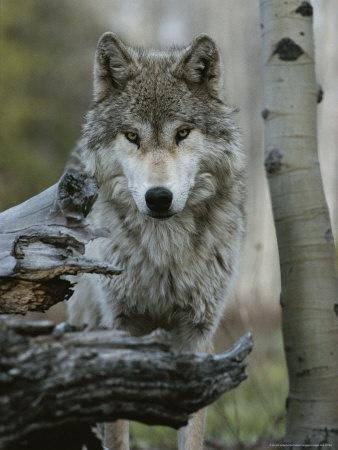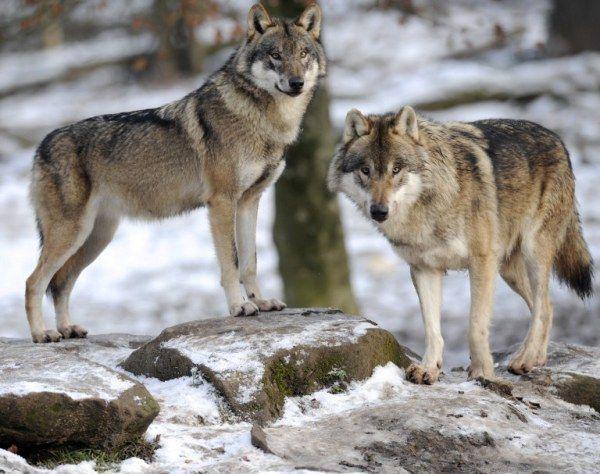The first image is the image on the left, the second image is the image on the right. Given the left and right images, does the statement "At least one wolf has its mouth open." hold true? Answer yes or no. No. 